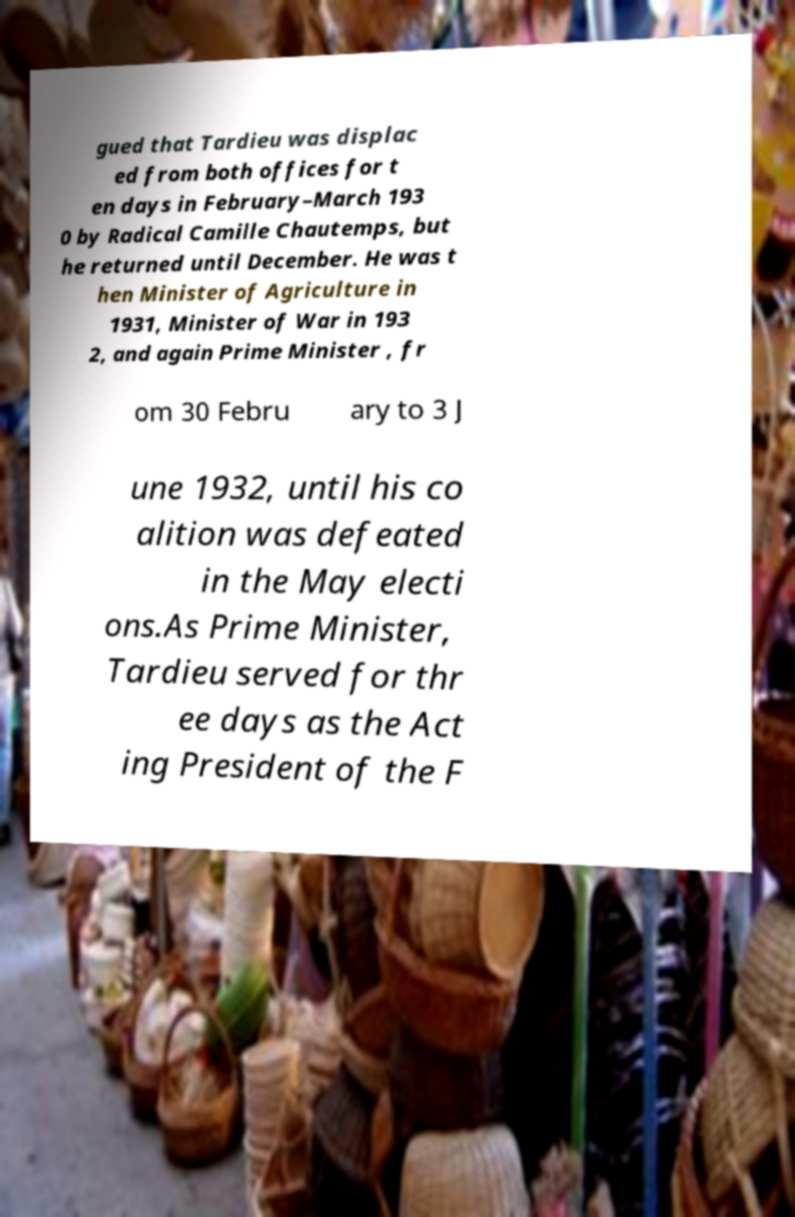Could you assist in decoding the text presented in this image and type it out clearly? gued that Tardieu was displac ed from both offices for t en days in February–March 193 0 by Radical Camille Chautemps, but he returned until December. He was t hen Minister of Agriculture in 1931, Minister of War in 193 2, and again Prime Minister , fr om 30 Febru ary to 3 J une 1932, until his co alition was defeated in the May electi ons.As Prime Minister, Tardieu served for thr ee days as the Act ing President of the F 